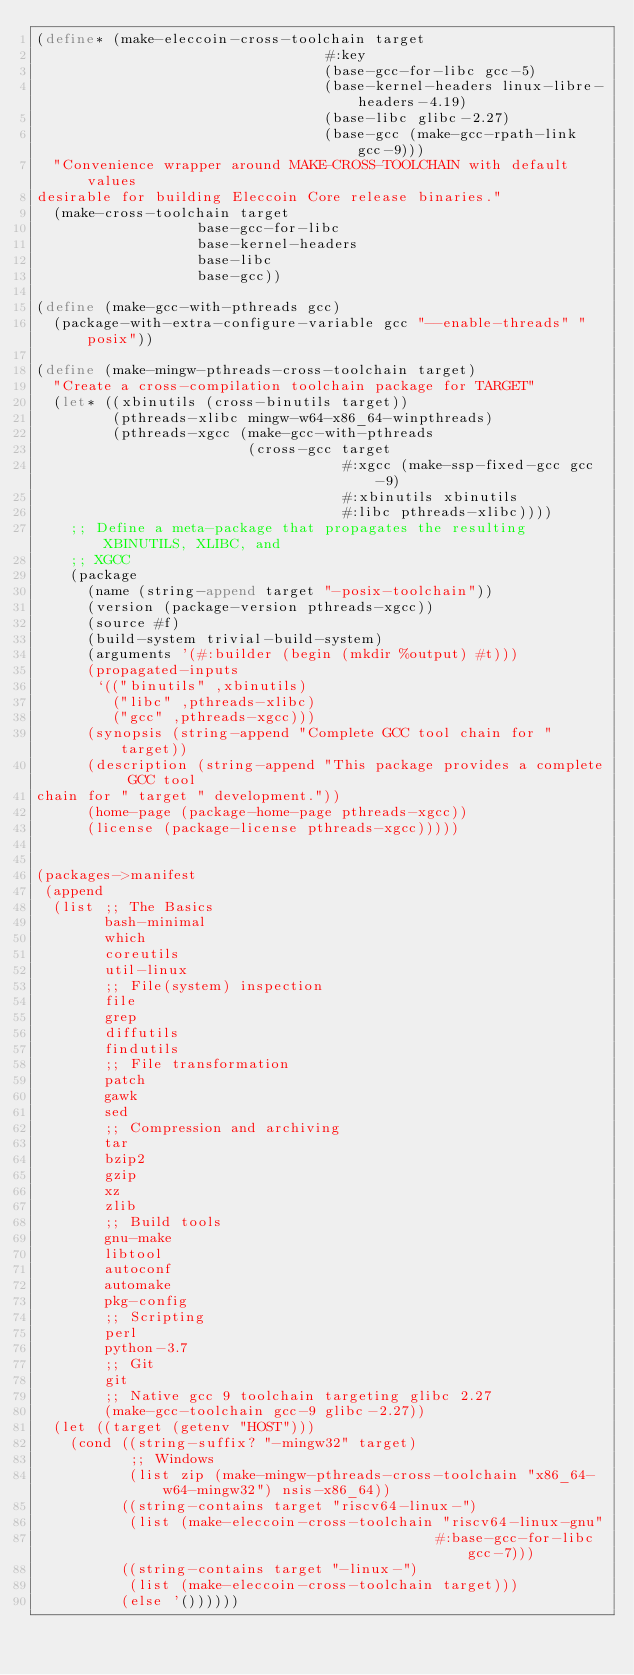<code> <loc_0><loc_0><loc_500><loc_500><_Scheme_>(define* (make-eleccoin-cross-toolchain target
                                  #:key
                                  (base-gcc-for-libc gcc-5)
                                  (base-kernel-headers linux-libre-headers-4.19)
                                  (base-libc glibc-2.27)
                                  (base-gcc (make-gcc-rpath-link gcc-9)))
  "Convenience wrapper around MAKE-CROSS-TOOLCHAIN with default values
desirable for building Eleccoin Core release binaries."
  (make-cross-toolchain target
                   base-gcc-for-libc
                   base-kernel-headers
                   base-libc
                   base-gcc))

(define (make-gcc-with-pthreads gcc)
  (package-with-extra-configure-variable gcc "--enable-threads" "posix"))

(define (make-mingw-pthreads-cross-toolchain target)
  "Create a cross-compilation toolchain package for TARGET"
  (let* ((xbinutils (cross-binutils target))
         (pthreads-xlibc mingw-w64-x86_64-winpthreads)
         (pthreads-xgcc (make-gcc-with-pthreads
                         (cross-gcc target
                                    #:xgcc (make-ssp-fixed-gcc gcc-9)
                                    #:xbinutils xbinutils
                                    #:libc pthreads-xlibc))))
    ;; Define a meta-package that propagates the resulting XBINUTILS, XLIBC, and
    ;; XGCC
    (package
      (name (string-append target "-posix-toolchain"))
      (version (package-version pthreads-xgcc))
      (source #f)
      (build-system trivial-build-system)
      (arguments '(#:builder (begin (mkdir %output) #t)))
      (propagated-inputs
       `(("binutils" ,xbinutils)
         ("libc" ,pthreads-xlibc)
         ("gcc" ,pthreads-xgcc)))
      (synopsis (string-append "Complete GCC tool chain for " target))
      (description (string-append "This package provides a complete GCC tool
chain for " target " development."))
      (home-page (package-home-page pthreads-xgcc))
      (license (package-license pthreads-xgcc)))))


(packages->manifest
 (append
  (list ;; The Basics
        bash-minimal
        which
        coreutils
        util-linux
        ;; File(system) inspection
        file
        grep
        diffutils
        findutils
        ;; File transformation
        patch
        gawk
        sed
        ;; Compression and archiving
        tar
        bzip2
        gzip
        xz
        zlib
        ;; Build tools
        gnu-make
        libtool
        autoconf
        automake
        pkg-config
        ;; Scripting
        perl
        python-3.7
        ;; Git
        git
        ;; Native gcc 9 toolchain targeting glibc 2.27
        (make-gcc-toolchain gcc-9 glibc-2.27))
  (let ((target (getenv "HOST")))
    (cond ((string-suffix? "-mingw32" target)
           ;; Windows
           (list zip (make-mingw-pthreads-cross-toolchain "x86_64-w64-mingw32") nsis-x86_64))
          ((string-contains target "riscv64-linux-")
           (list (make-eleccoin-cross-toolchain "riscv64-linux-gnu"
                                               #:base-gcc-for-libc gcc-7)))
          ((string-contains target "-linux-")
           (list (make-eleccoin-cross-toolchain target)))
          (else '())))))
</code> 